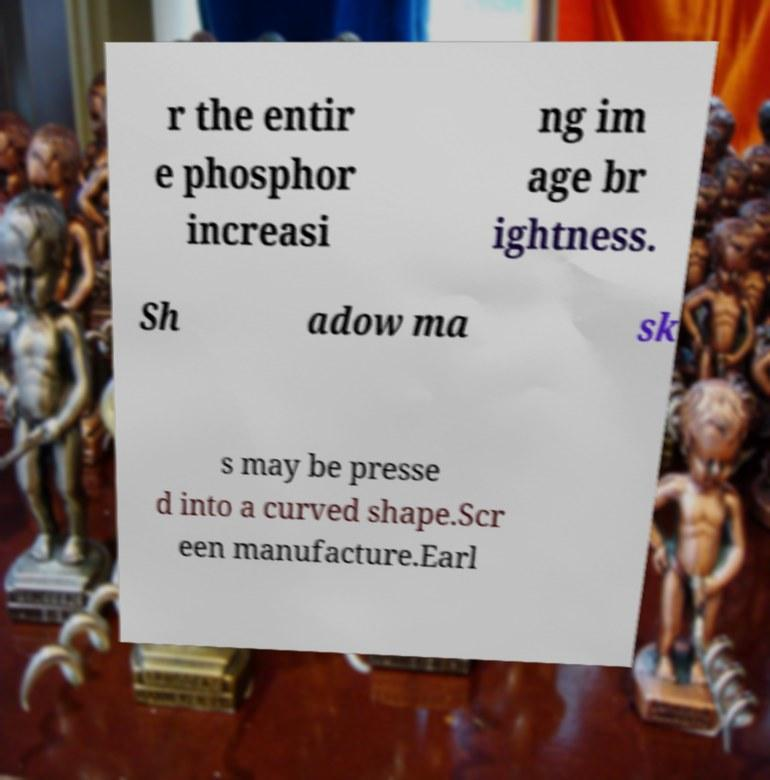For documentation purposes, I need the text within this image transcribed. Could you provide that? r the entir e phosphor increasi ng im age br ightness. Sh adow ma sk s may be presse d into a curved shape.Scr een manufacture.Earl 